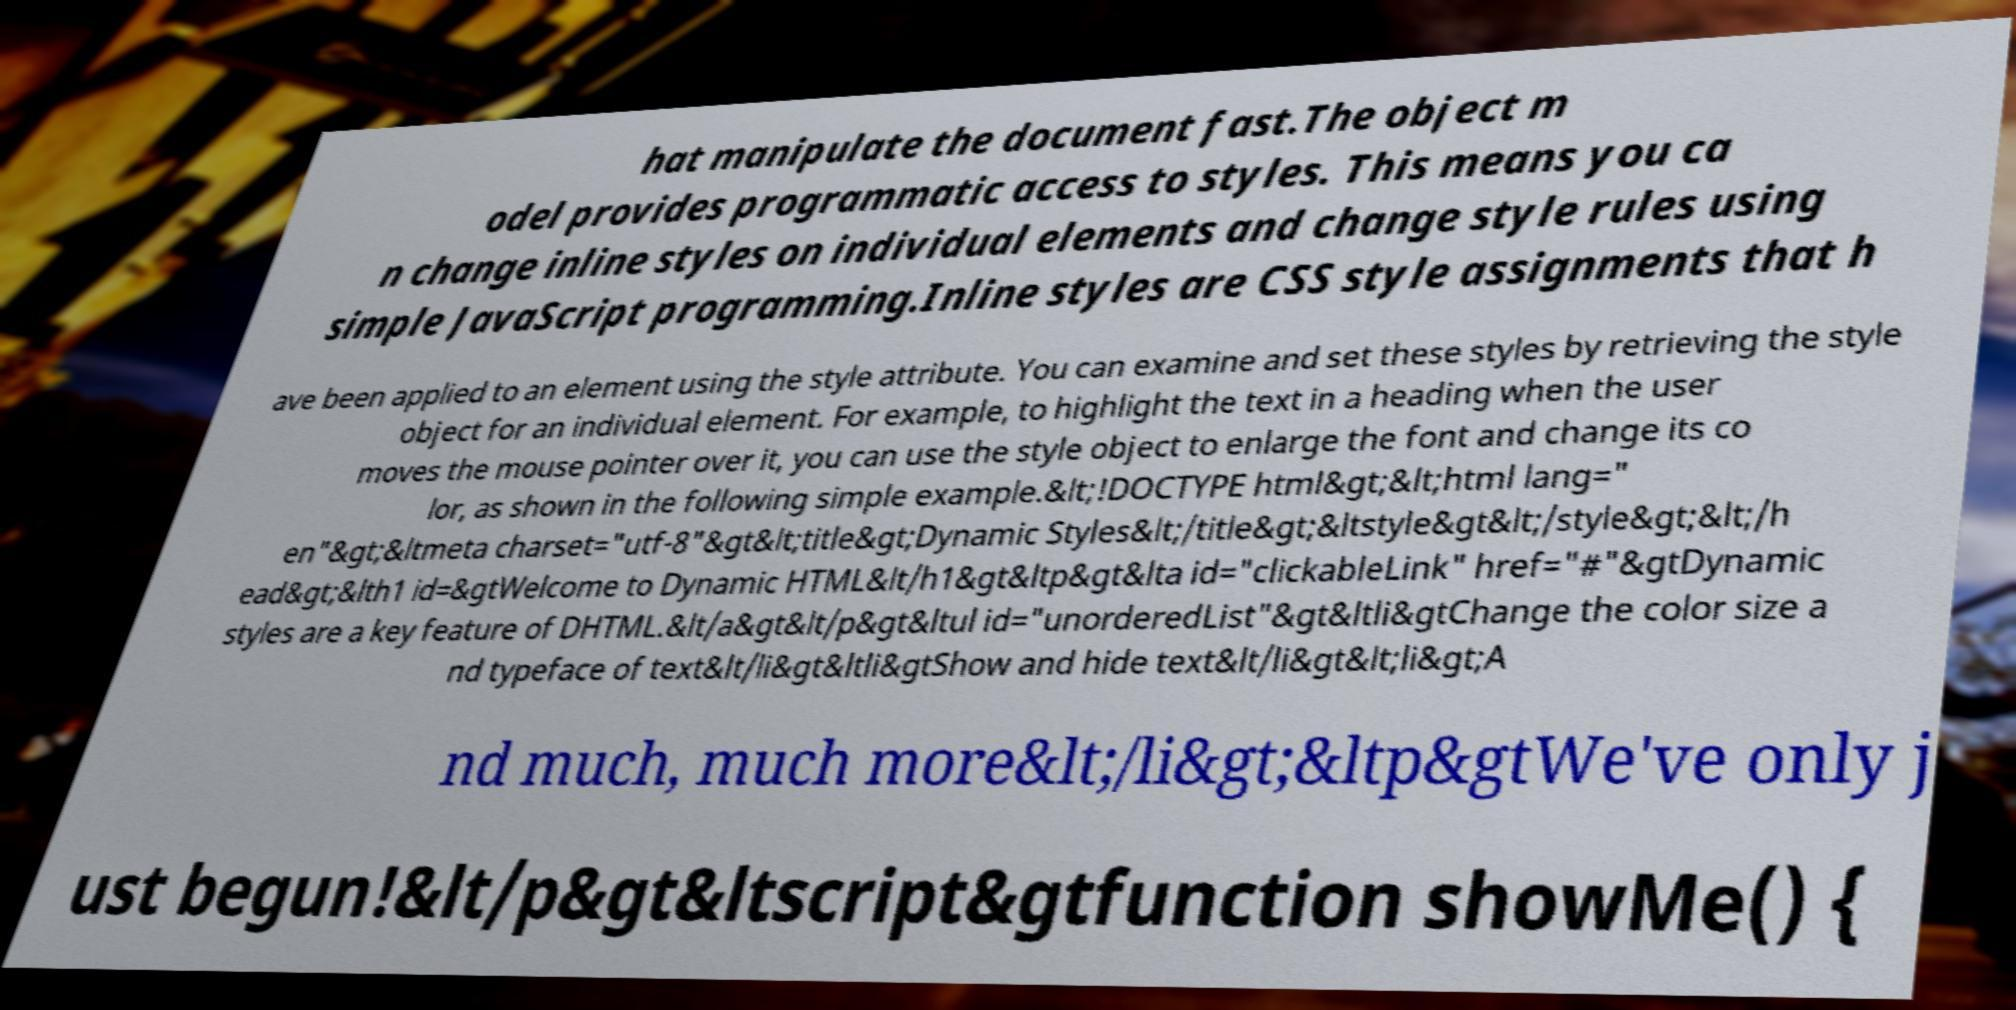I need the written content from this picture converted into text. Can you do that? hat manipulate the document fast.The object m odel provides programmatic access to styles. This means you ca n change inline styles on individual elements and change style rules using simple JavaScript programming.Inline styles are CSS style assignments that h ave been applied to an element using the style attribute. You can examine and set these styles by retrieving the style object for an individual element. For example, to highlight the text in a heading when the user moves the mouse pointer over it, you can use the style object to enlarge the font and change its co lor, as shown in the following simple example.&lt;!DOCTYPE html&gt;&lt;html lang=" en"&gt;&ltmeta charset="utf-8"&gt&lt;title&gt;Dynamic Styles&lt;/title&gt;&ltstyle&gt&lt;/style&gt;&lt;/h ead&gt;&lth1 id=&gtWelcome to Dynamic HTML&lt/h1&gt&ltp&gt&lta id="clickableLink" href="#"&gtDynamic styles are a key feature of DHTML.&lt/a&gt&lt/p&gt&ltul id="unorderedList"&gt&ltli&gtChange the color size a nd typeface of text&lt/li&gt&ltli&gtShow and hide text&lt/li&gt&lt;li&gt;A nd much, much more&lt;/li&gt;&ltp&gtWe've only j ust begun!&lt/p&gt&ltscript&gtfunction showMe() { 